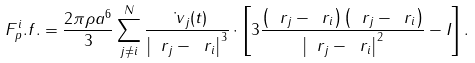Convert formula to latex. <formula><loc_0><loc_0><loc_500><loc_500>\ F ^ { i } _ { p } . f . = \frac { 2 \pi \rho a ^ { 6 } } { 3 } \sum _ { j \ne i } ^ { N } \frac { \dot { \ v } _ { j } ( t ) } { \left | \ r _ { j } - \ r _ { i } \right | ^ { 3 } } \cdot \left [ 3 \frac { \left ( \ r _ { j } - \ r _ { i } \right ) \left ( \ r _ { j } - \ r _ { i } \right ) } { \left | \ r _ { j } - \ r _ { i } \right | ^ { 2 } } - I \right ] .</formula> 